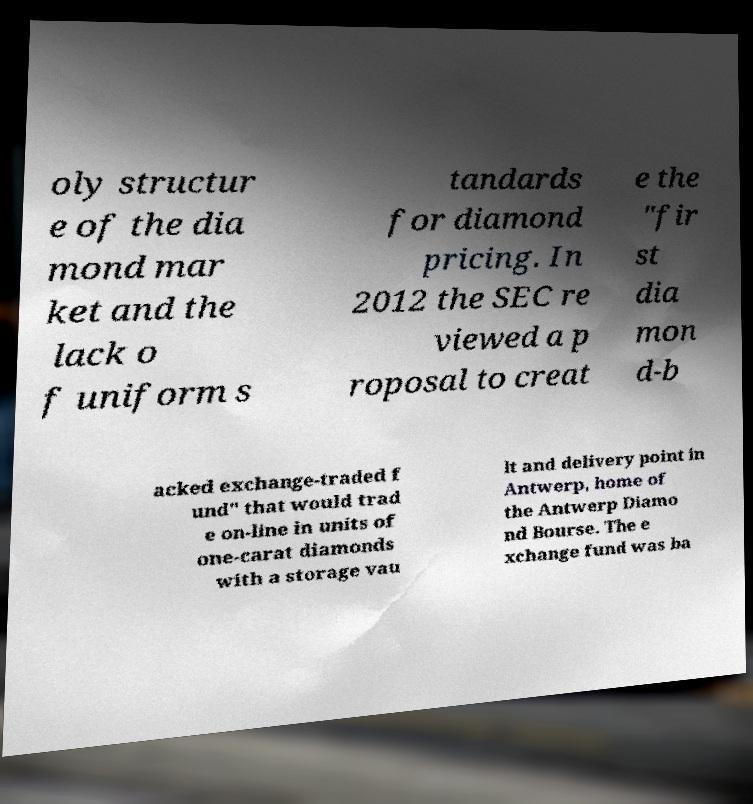I need the written content from this picture converted into text. Can you do that? oly structur e of the dia mond mar ket and the lack o f uniform s tandards for diamond pricing. In 2012 the SEC re viewed a p roposal to creat e the "fir st dia mon d-b acked exchange-traded f und" that would trad e on-line in units of one-carat diamonds with a storage vau lt and delivery point in Antwerp, home of the Antwerp Diamo nd Bourse. The e xchange fund was ba 